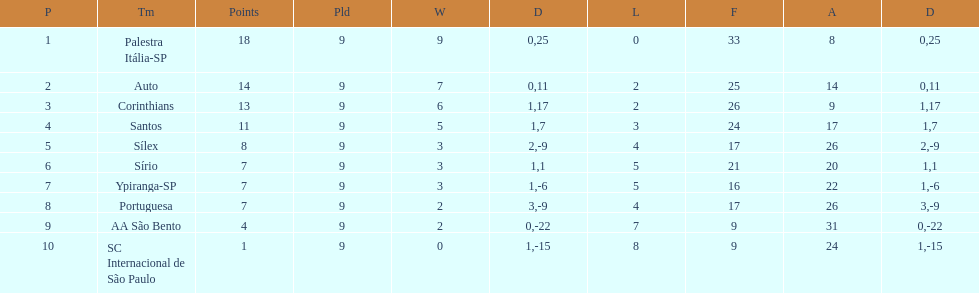How many points did the brazilian football team auto get in 1926? 14. 